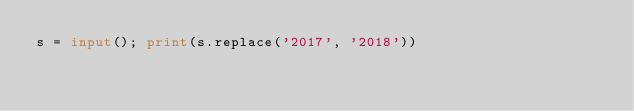<code> <loc_0><loc_0><loc_500><loc_500><_Python_>s = input(); print(s.replace('2017', '2018'))</code> 